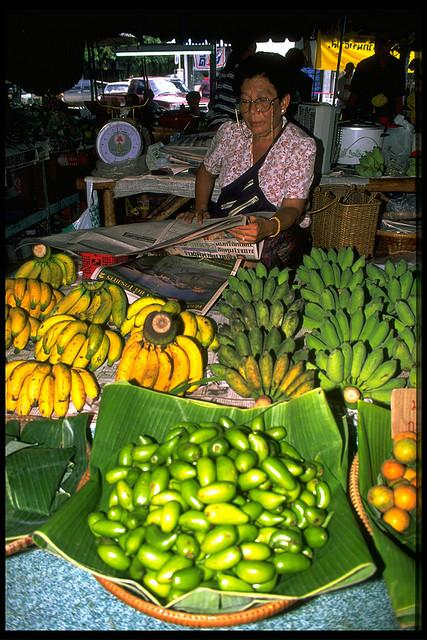What purpose does the weight in the back serve? pricing 